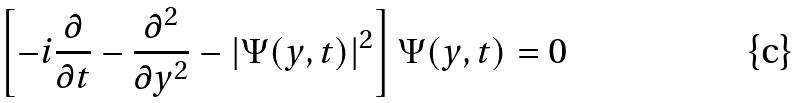Convert formula to latex. <formula><loc_0><loc_0><loc_500><loc_500>\left [ - i \frac { \partial } { \partial t } - \frac { \partial ^ { 2 } } { \partial y ^ { 2 } } - | \Psi ( y , t ) | ^ { 2 } \right ] \Psi ( y , t ) = 0</formula> 